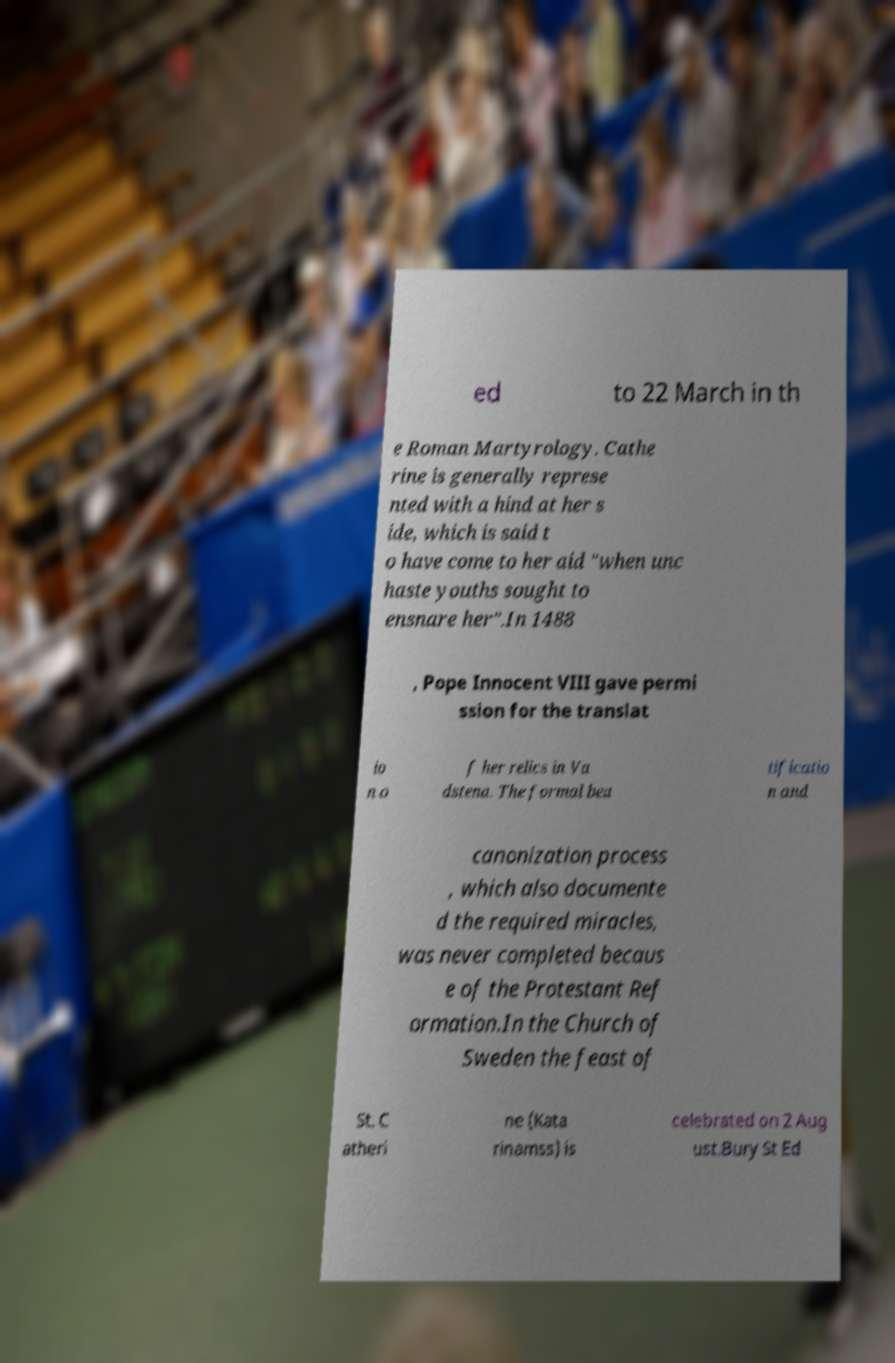Can you accurately transcribe the text from the provided image for me? ed to 22 March in th e Roman Martyrology. Cathe rine is generally represe nted with a hind at her s ide, which is said t o have come to her aid "when unc haste youths sought to ensnare her".In 1488 , Pope Innocent VIII gave permi ssion for the translat io n o f her relics in Va dstena. The formal bea tificatio n and canonization process , which also documente d the required miracles, was never completed becaus e of the Protestant Ref ormation.In the Church of Sweden the feast of St. C atheri ne (Kata rinamss) is celebrated on 2 Aug ust.Bury St Ed 